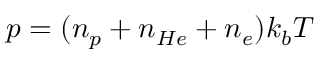<formula> <loc_0><loc_0><loc_500><loc_500>p = ( n _ { p } + n _ { H e } + n _ { e } ) k _ { b } T</formula> 